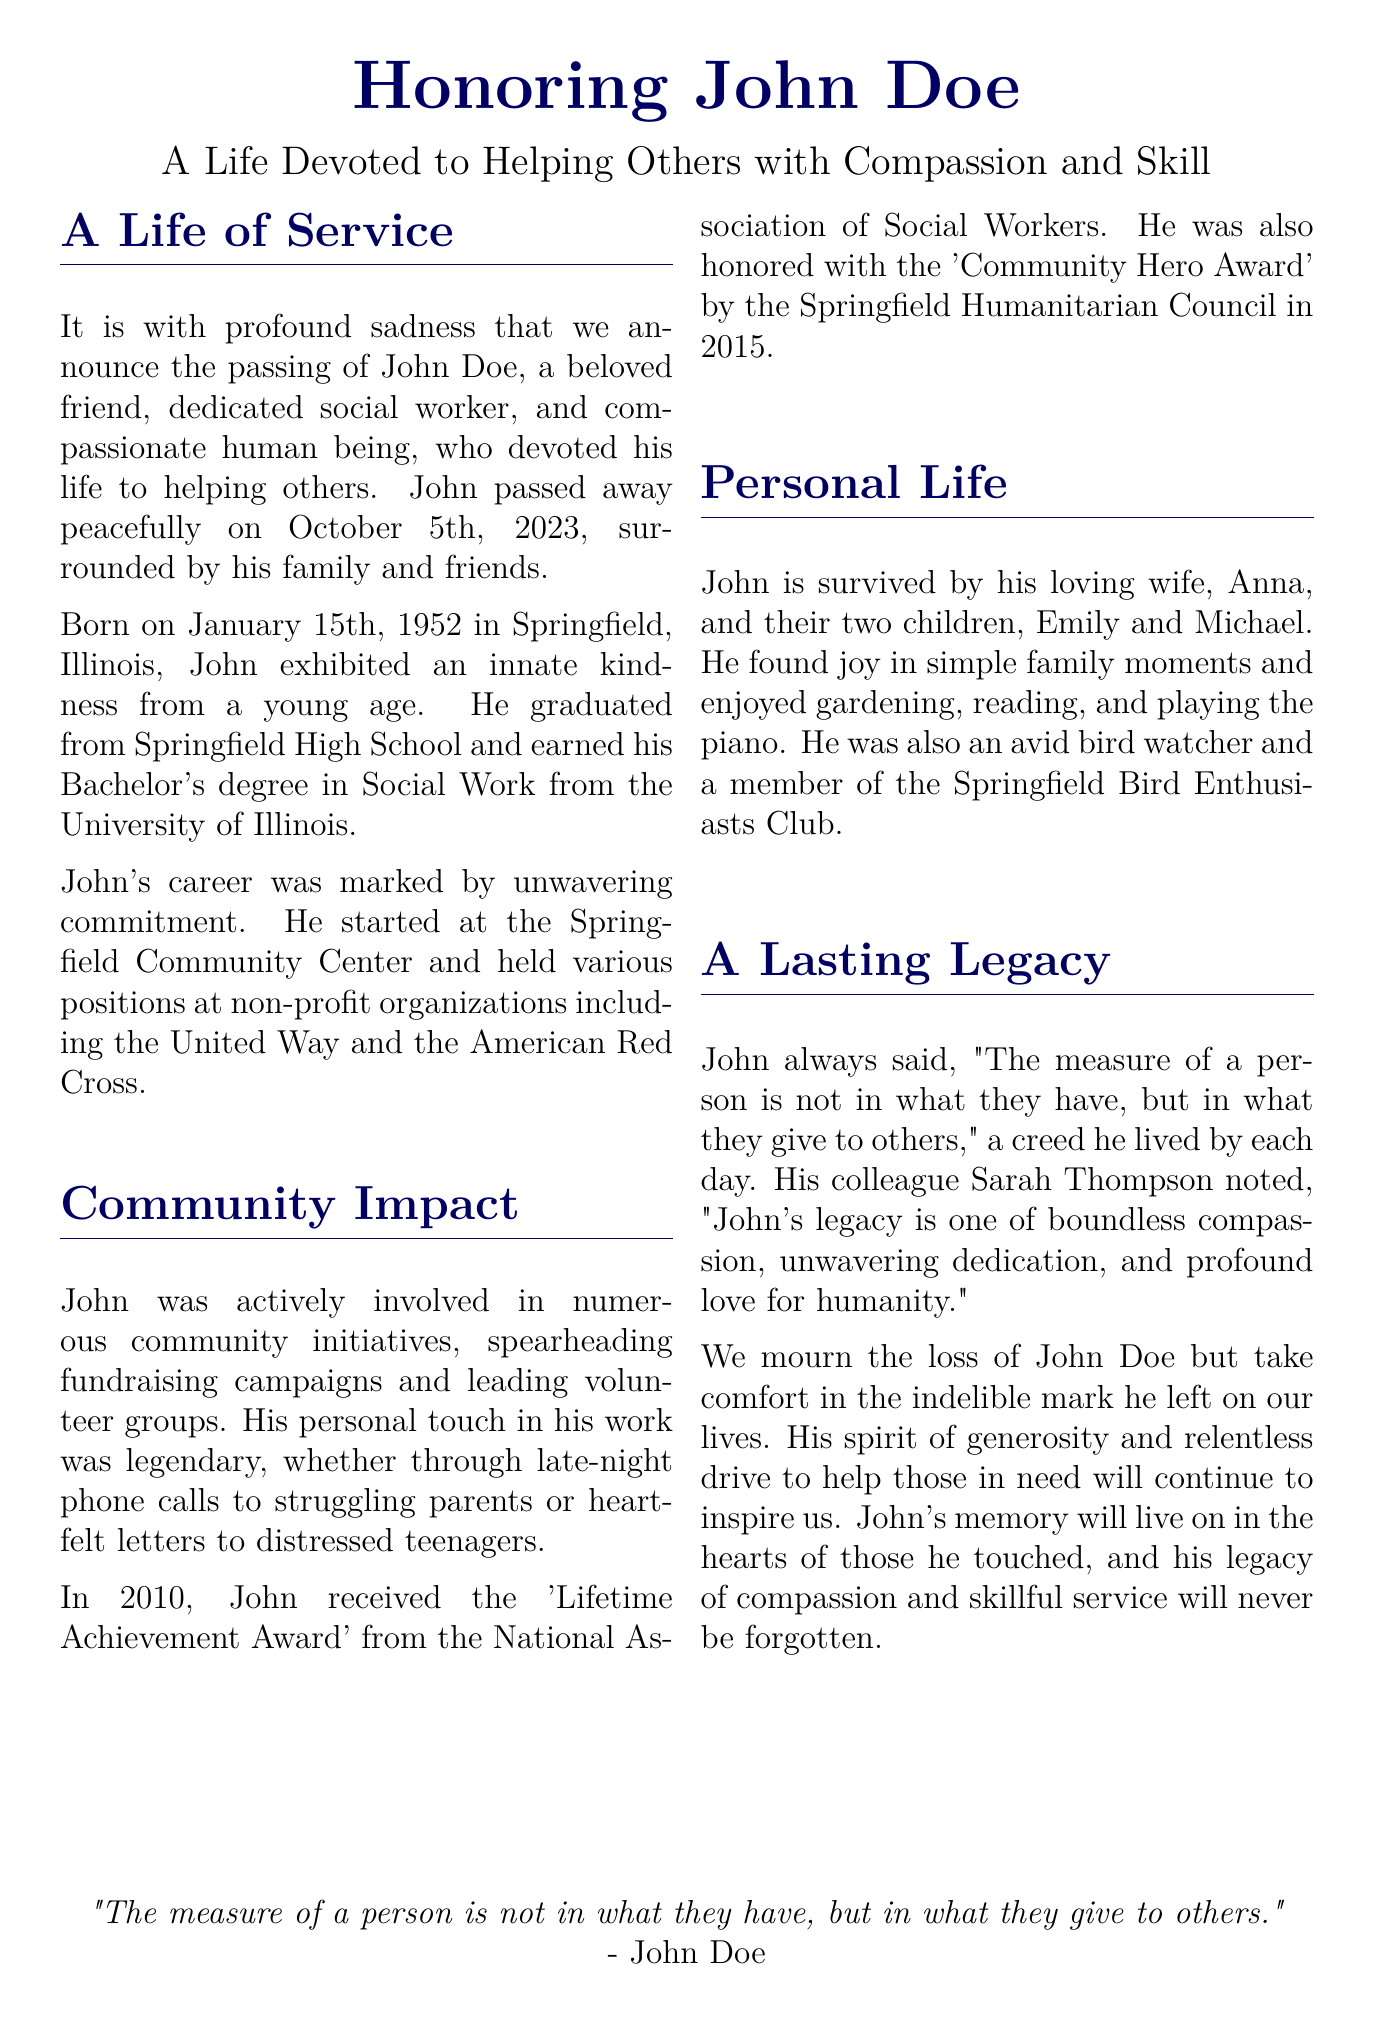what was John Doe's profession? John Doe was a dedicated social worker who devoted his life to helping others.
Answer: social worker when did John Doe pass away? The document states that John passed away peacefully on October 5th, 2023.
Answer: October 5th, 2023 where did John earn his Bachelor's degree? John earned his Bachelor's degree in Social Work from the University of Illinois.
Answer: University of Illinois what award did John receive in 2010? In 2010, John received the 'Lifetime Achievement Award' from the National Association of Social Workers.
Answer: 'Lifetime Achievement Award' who described John's legacy in the document? John's colleague Sarah Thompson described his legacy of boundless compassion and dedication.
Answer: Sarah Thompson what was one of John’s hobbies mentioned? The document mentions that John was an avid bird watcher.
Answer: bird watcher how many children did John have? John is survived by two children, Emily and Michael.
Answer: two what was John Doe's quote about measuring a person? John said, "The measure of a person is not in what they have, but in what they give to others."
Answer: "The measure of a person is not in what they have, but in what they give to others." 